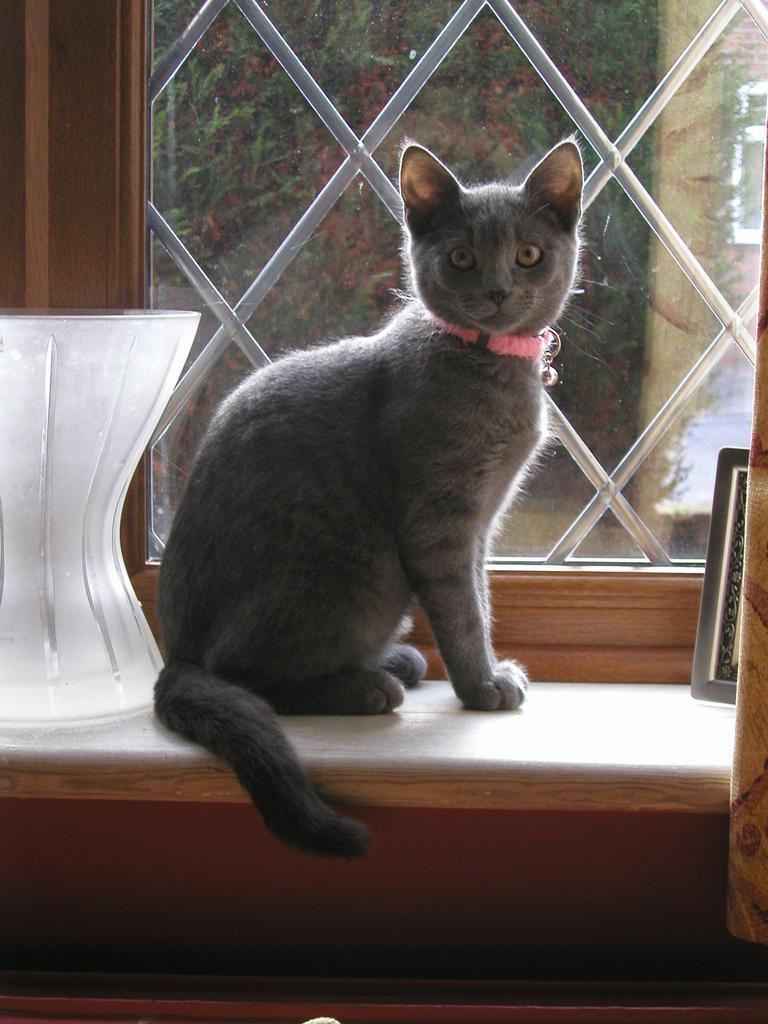Describe this image in one or two sentences. In this image we can see a cat on the table, also we can see a vase, and a photo frame on the table, there is a window, plants, and the curtain. 